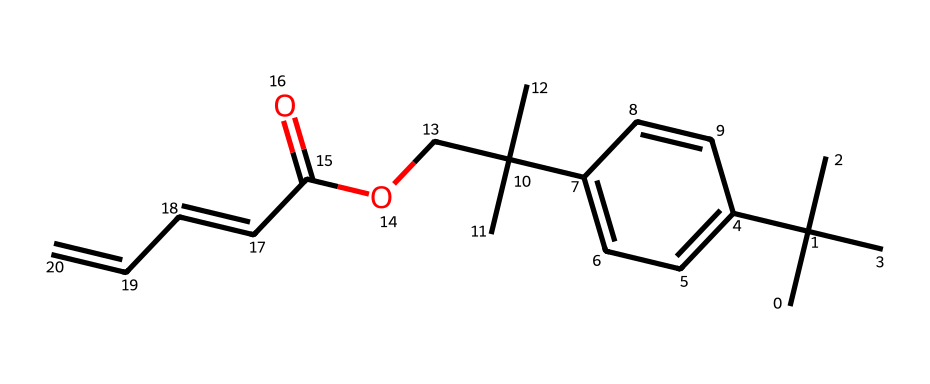What is the molecular formula of the compound represented by this SMILES? By analyzing the SMILES representation, the numbers of each type of atom can be counted: there are 19 carbon atoms, 24 hydrogen atoms, and 2 oxygen atoms. Thus, the molecular formula is C19H24O2.
Answer: C19H24O2 How many double bonds are present in this chemical structure? The SMILES shows regions such as "C=C" which indicate double bonds between carbon atoms. Counting these regions leads to the identification of two double bonds within the structure.
Answer: 2 What type of functional group is indicated by "COC(=O)" in the structure? The "COC(=O)" part features a carbonyl group (C=O) bonded to an oxygen atom with other carbons, which classifies it as an ester functional group.
Answer: ester Is the chemical likely to be hydrophobic or hydrophilic based on its structure? The presence of a long carbon chain with many hydrogens suggests that this chemical is more hydrophobic, meaning it repels water, which is typical for organic compounds with large hydrocarbon components.
Answer: hydrophobic What is the approximate number of rings present in this structure? Upon examining the structure, there appears to be one cyclohexene ring in the molecule, contributing to its cyclic character. Therefore, the chemical contains one ring.
Answer: 1 Identify an aromatic group in the structure. The structure contains a benzene ring, identifiable through the alternating double bonds in its six-membered carbon structure, indicating that it has an aromatic group.
Answer: benzene ring 